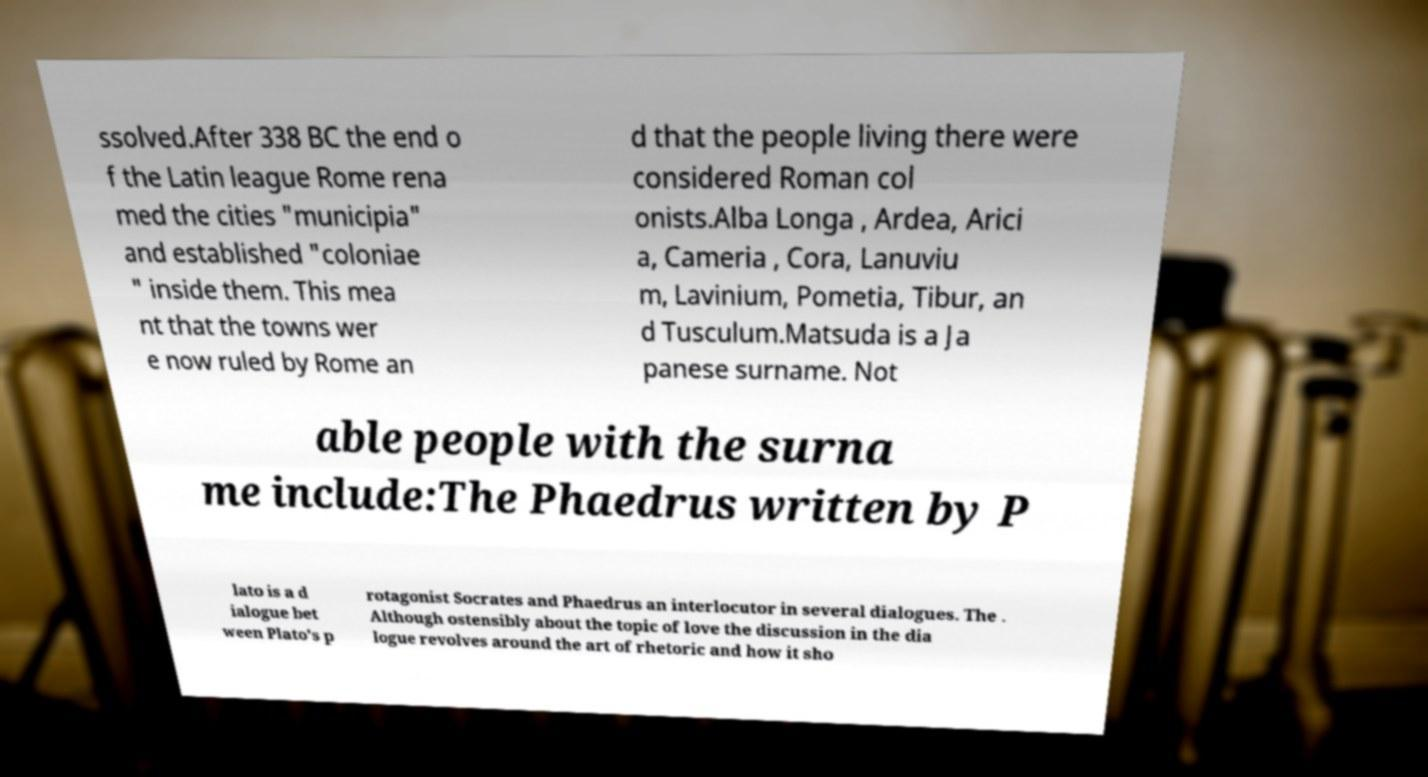Could you assist in decoding the text presented in this image and type it out clearly? ssolved.After 338 BC the end o f the Latin league Rome rena med the cities "municipia" and established "coloniae " inside them. This mea nt that the towns wer e now ruled by Rome an d that the people living there were considered Roman col onists.Alba Longa , Ardea, Arici a, Cameria , Cora, Lanuviu m, Lavinium, Pometia, Tibur, an d Tusculum.Matsuda is a Ja panese surname. Not able people with the surna me include:The Phaedrus written by P lato is a d ialogue bet ween Plato's p rotagonist Socrates and Phaedrus an interlocutor in several dialogues. The . Although ostensibly about the topic of love the discussion in the dia logue revolves around the art of rhetoric and how it sho 